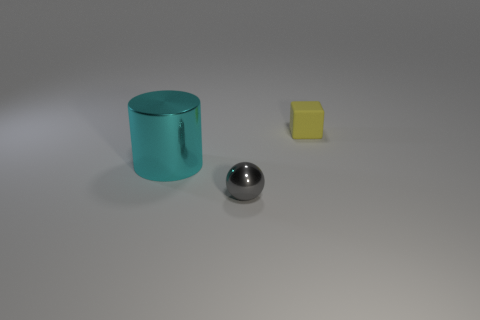Are there fewer cyan cylinders than green shiny blocks?
Give a very brief answer. No. What material is the gray thing that is the same size as the yellow matte object?
Your response must be concise. Metal. There is a object that is on the right side of the ball; is it the same size as the shiny thing in front of the big cyan object?
Your answer should be compact. Yes. Is there a big cylinder made of the same material as the tiny gray ball?
Offer a very short reply. Yes. What number of things are shiny objects that are on the left side of the tiny gray thing or small cubes?
Keep it short and to the point. 2. Is the material of the tiny thing that is behind the sphere the same as the gray thing?
Give a very brief answer. No. Does the tiny yellow matte object have the same shape as the small gray shiny thing?
Make the answer very short. No. How many cyan shiny cylinders are on the left side of the tiny object that is right of the gray object?
Offer a terse response. 1. Is the small gray ball made of the same material as the object left of the small metallic object?
Make the answer very short. Yes. There is a metallic thing left of the tiny gray object; what is its shape?
Your response must be concise. Cylinder. 